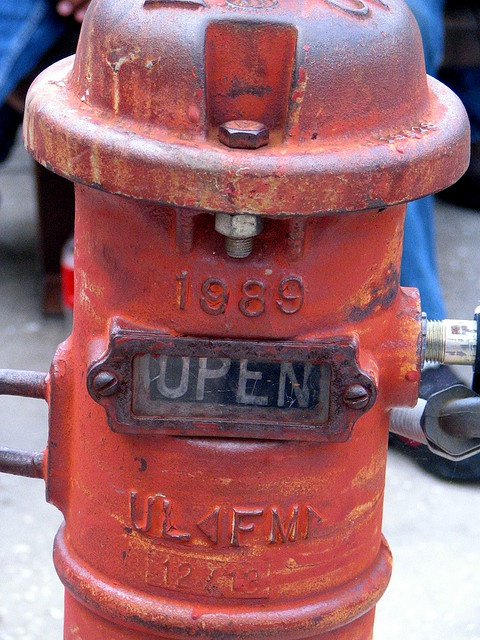Describe the objects in this image and their specific colors. I can see a fire hydrant in blue, brown, salmon, and maroon tones in this image. 